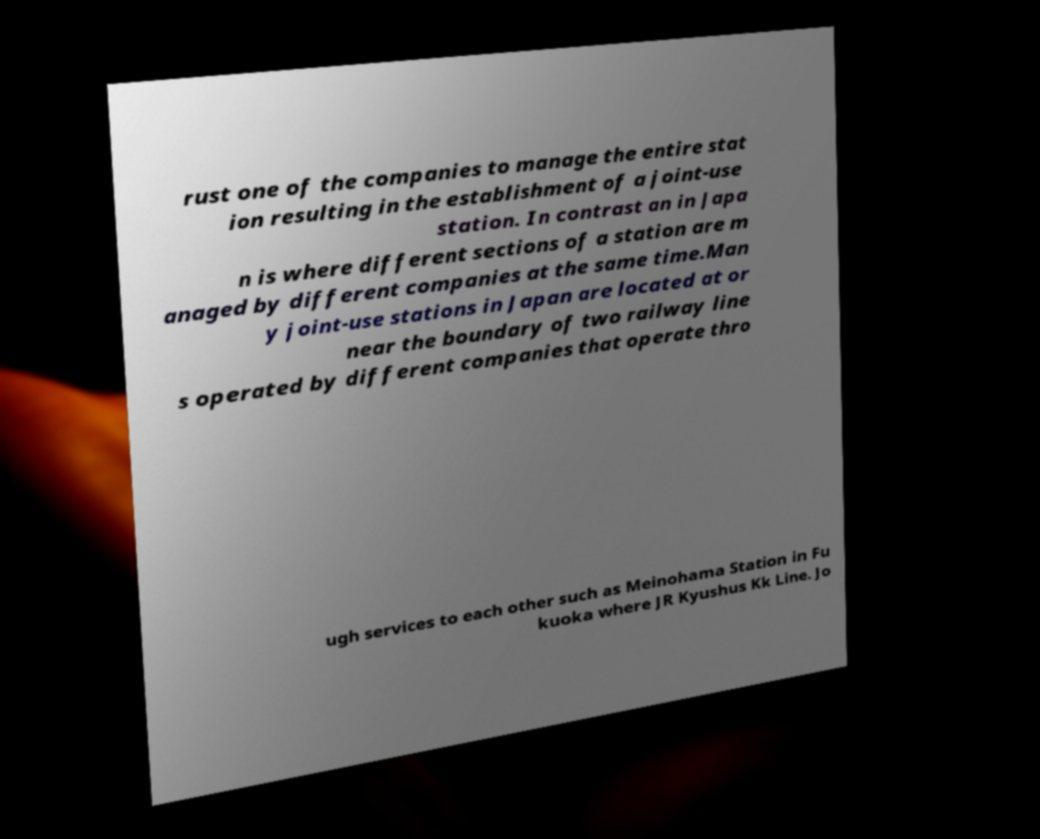I need the written content from this picture converted into text. Can you do that? rust one of the companies to manage the entire stat ion resulting in the establishment of a joint-use station. In contrast an in Japa n is where different sections of a station are m anaged by different companies at the same time.Man y joint-use stations in Japan are located at or near the boundary of two railway line s operated by different companies that operate thro ugh services to each other such as Meinohama Station in Fu kuoka where JR Kyushus Kk Line. Jo 